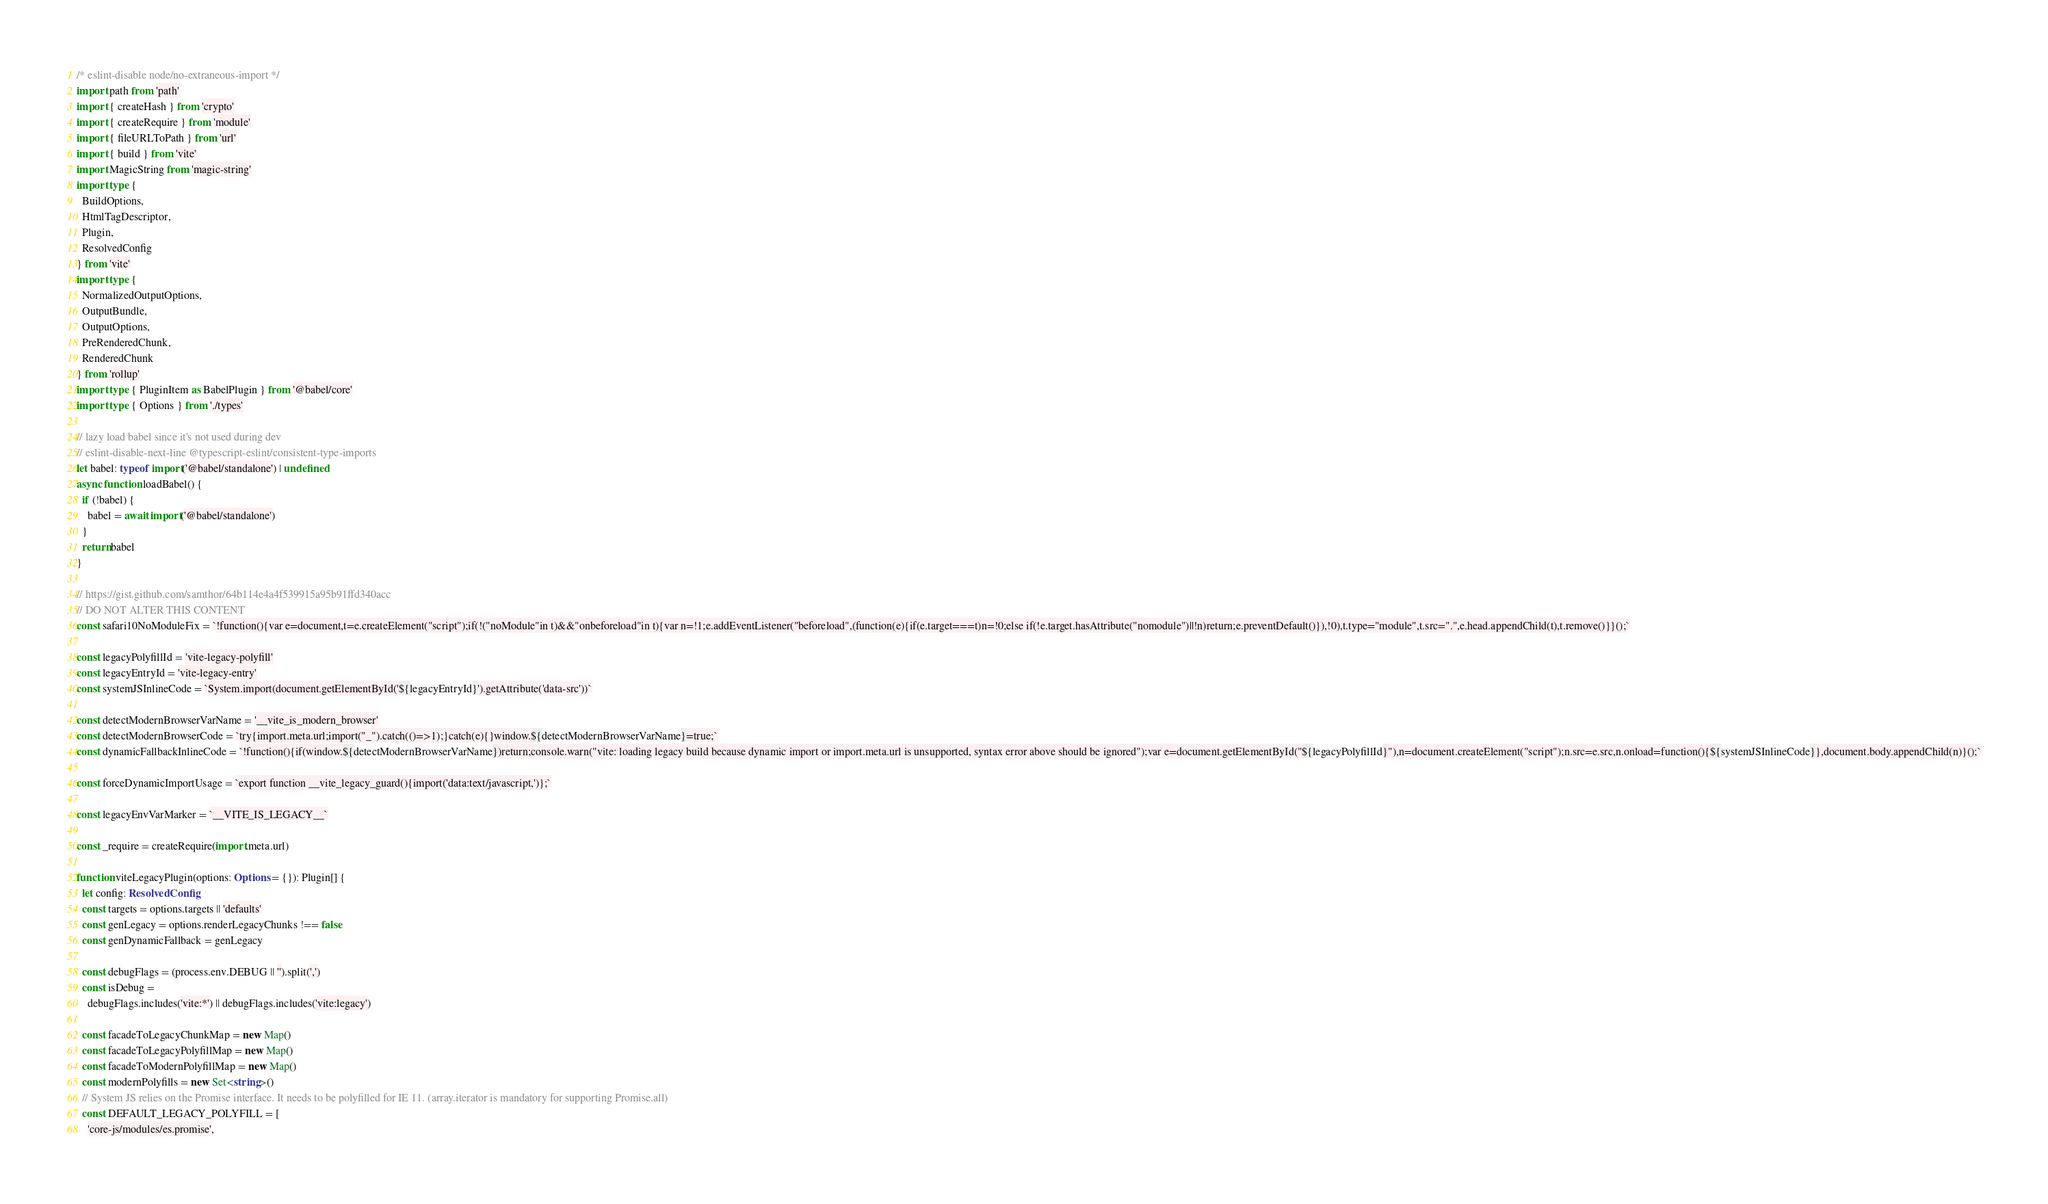<code> <loc_0><loc_0><loc_500><loc_500><_TypeScript_>/* eslint-disable node/no-extraneous-import */
import path from 'path'
import { createHash } from 'crypto'
import { createRequire } from 'module'
import { fileURLToPath } from 'url'
import { build } from 'vite'
import MagicString from 'magic-string'
import type {
  BuildOptions,
  HtmlTagDescriptor,
  Plugin,
  ResolvedConfig
} from 'vite'
import type {
  NormalizedOutputOptions,
  OutputBundle,
  OutputOptions,
  PreRenderedChunk,
  RenderedChunk
} from 'rollup'
import type { PluginItem as BabelPlugin } from '@babel/core'
import type { Options } from './types'

// lazy load babel since it's not used during dev
// eslint-disable-next-line @typescript-eslint/consistent-type-imports
let babel: typeof import('@babel/standalone') | undefined
async function loadBabel() {
  if (!babel) {
    babel = await import('@babel/standalone')
  }
  return babel
}

// https://gist.github.com/samthor/64b114e4a4f539915a95b91ffd340acc
// DO NOT ALTER THIS CONTENT
const safari10NoModuleFix = `!function(){var e=document,t=e.createElement("script");if(!("noModule"in t)&&"onbeforeload"in t){var n=!1;e.addEventListener("beforeload",(function(e){if(e.target===t)n=!0;else if(!e.target.hasAttribute("nomodule")||!n)return;e.preventDefault()}),!0),t.type="module",t.src=".",e.head.appendChild(t),t.remove()}}();`

const legacyPolyfillId = 'vite-legacy-polyfill'
const legacyEntryId = 'vite-legacy-entry'
const systemJSInlineCode = `System.import(document.getElementById('${legacyEntryId}').getAttribute('data-src'))`

const detectModernBrowserVarName = '__vite_is_modern_browser'
const detectModernBrowserCode = `try{import.meta.url;import("_").catch(()=>1);}catch(e){}window.${detectModernBrowserVarName}=true;`
const dynamicFallbackInlineCode = `!function(){if(window.${detectModernBrowserVarName})return;console.warn("vite: loading legacy build because dynamic import or import.meta.url is unsupported, syntax error above should be ignored");var e=document.getElementById("${legacyPolyfillId}"),n=document.createElement("script");n.src=e.src,n.onload=function(){${systemJSInlineCode}},document.body.appendChild(n)}();`

const forceDynamicImportUsage = `export function __vite_legacy_guard(){import('data:text/javascript,')};`

const legacyEnvVarMarker = `__VITE_IS_LEGACY__`

const _require = createRequire(import.meta.url)

function viteLegacyPlugin(options: Options = {}): Plugin[] {
  let config: ResolvedConfig
  const targets = options.targets || 'defaults'
  const genLegacy = options.renderLegacyChunks !== false
  const genDynamicFallback = genLegacy

  const debugFlags = (process.env.DEBUG || '').split(',')
  const isDebug =
    debugFlags.includes('vite:*') || debugFlags.includes('vite:legacy')

  const facadeToLegacyChunkMap = new Map()
  const facadeToLegacyPolyfillMap = new Map()
  const facadeToModernPolyfillMap = new Map()
  const modernPolyfills = new Set<string>()
  // System JS relies on the Promise interface. It needs to be polyfilled for IE 11. (array.iterator is mandatory for supporting Promise.all)
  const DEFAULT_LEGACY_POLYFILL = [
    'core-js/modules/es.promise',</code> 